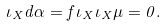<formula> <loc_0><loc_0><loc_500><loc_500>\iota _ { X } d \alpha = f \iota _ { X } \iota _ { X } \mu = 0 .</formula> 